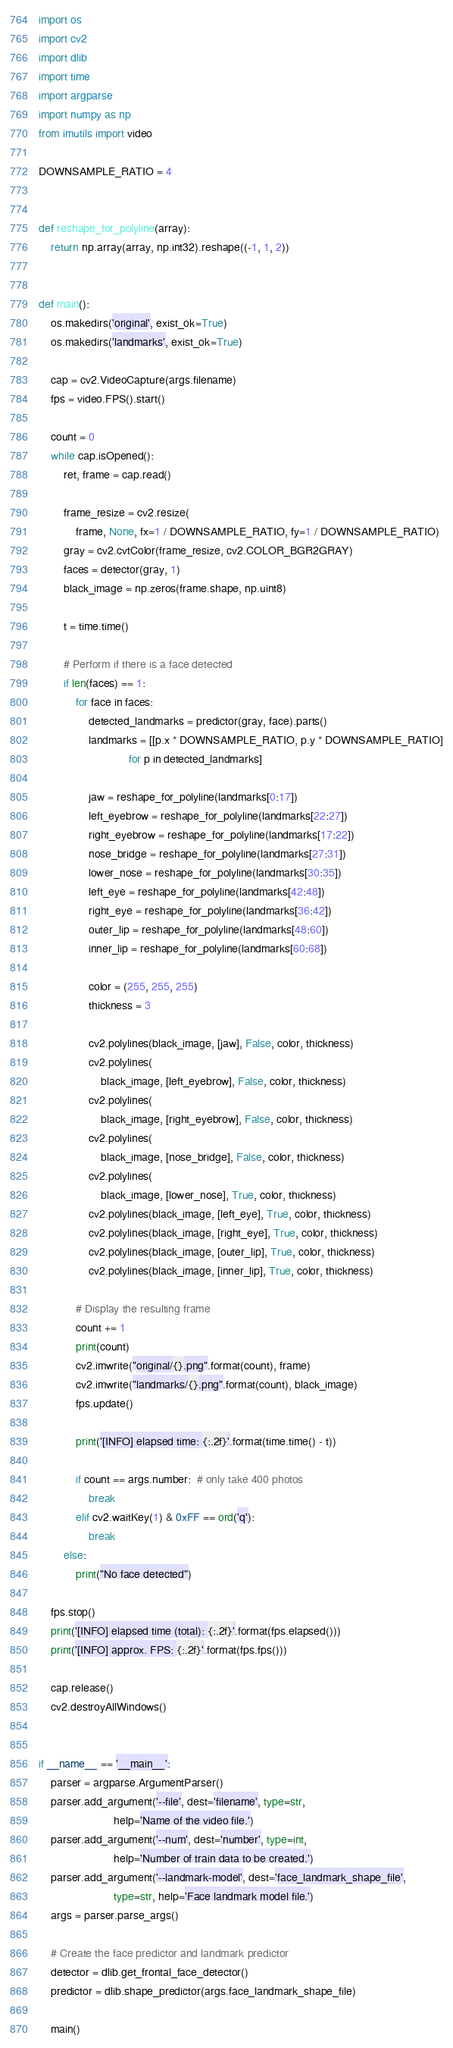Convert code to text. <code><loc_0><loc_0><loc_500><loc_500><_Python_>import os
import cv2
import dlib
import time
import argparse
import numpy as np
from imutils import video

DOWNSAMPLE_RATIO = 4


def reshape_for_polyline(array):
    return np.array(array, np.int32).reshape((-1, 1, 2))


def main():
    os.makedirs('original', exist_ok=True)
    os.makedirs('landmarks', exist_ok=True)

    cap = cv2.VideoCapture(args.filename)
    fps = video.FPS().start()

    count = 0
    while cap.isOpened():
        ret, frame = cap.read()

        frame_resize = cv2.resize(
            frame, None, fx=1 / DOWNSAMPLE_RATIO, fy=1 / DOWNSAMPLE_RATIO)
        gray = cv2.cvtColor(frame_resize, cv2.COLOR_BGR2GRAY)
        faces = detector(gray, 1)
        black_image = np.zeros(frame.shape, np.uint8)

        t = time.time()

        # Perform if there is a face detected
        if len(faces) == 1:
            for face in faces:
                detected_landmarks = predictor(gray, face).parts()
                landmarks = [[p.x * DOWNSAMPLE_RATIO, p.y * DOWNSAMPLE_RATIO]
                             for p in detected_landmarks]

                jaw = reshape_for_polyline(landmarks[0:17])
                left_eyebrow = reshape_for_polyline(landmarks[22:27])
                right_eyebrow = reshape_for_polyline(landmarks[17:22])
                nose_bridge = reshape_for_polyline(landmarks[27:31])
                lower_nose = reshape_for_polyline(landmarks[30:35])
                left_eye = reshape_for_polyline(landmarks[42:48])
                right_eye = reshape_for_polyline(landmarks[36:42])
                outer_lip = reshape_for_polyline(landmarks[48:60])
                inner_lip = reshape_for_polyline(landmarks[60:68])

                color = (255, 255, 255)
                thickness = 3

                cv2.polylines(black_image, [jaw], False, color, thickness)
                cv2.polylines(
                    black_image, [left_eyebrow], False, color, thickness)
                cv2.polylines(
                    black_image, [right_eyebrow], False, color, thickness)
                cv2.polylines(
                    black_image, [nose_bridge], False, color, thickness)
                cv2.polylines(
                    black_image, [lower_nose], True, color, thickness)
                cv2.polylines(black_image, [left_eye], True, color, thickness)
                cv2.polylines(black_image, [right_eye], True, color, thickness)
                cv2.polylines(black_image, [outer_lip], True, color, thickness)
                cv2.polylines(black_image, [inner_lip], True, color, thickness)

            # Display the resulting frame
            count += 1
            print(count)
            cv2.imwrite("original/{}.png".format(count), frame)
            cv2.imwrite("landmarks/{}.png".format(count), black_image)
            fps.update()

            print('[INFO] elapsed time: {:.2f}'.format(time.time() - t))

            if count == args.number:  # only take 400 photos
                break
            elif cv2.waitKey(1) & 0xFF == ord('q'):
                break
        else:
            print("No face detected")

    fps.stop()
    print('[INFO] elapsed time (total): {:.2f}'.format(fps.elapsed()))
    print('[INFO] approx. FPS: {:.2f}'.format(fps.fps()))

    cap.release()
    cv2.destroyAllWindows()


if __name__ == '__main__':
    parser = argparse.ArgumentParser()
    parser.add_argument('--file', dest='filename', type=str,
                        help='Name of the video file.')
    parser.add_argument('--num', dest='number', type=int,
                        help='Number of train data to be created.')
    parser.add_argument('--landmark-model', dest='face_landmark_shape_file',
                        type=str, help='Face landmark model file.')
    args = parser.parse_args()

    # Create the face predictor and landmark predictor
    detector = dlib.get_frontal_face_detector()
    predictor = dlib.shape_predictor(args.face_landmark_shape_file)

    main()
</code> 